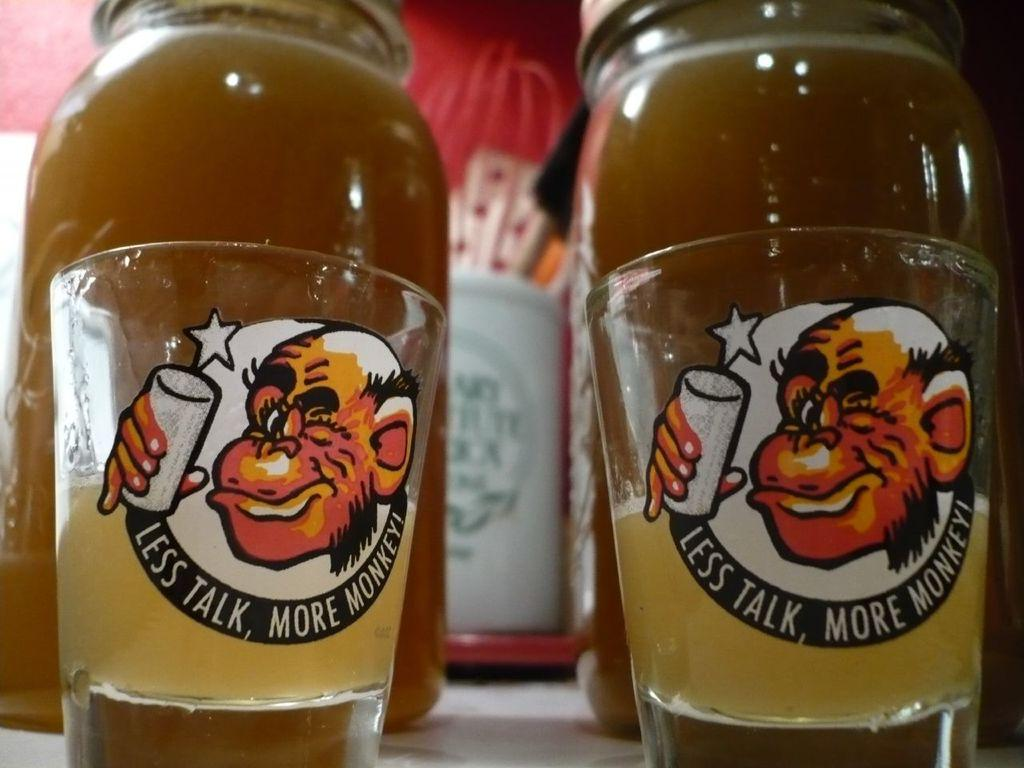What type of containers are present in the image? There are bottles with drinks in the image. What else can be seen in the image besides the bottles? There are glasses in the image. How are the glasses decorated or marked? Stickers are attached to the glasses. What type of wheel can be seen in the image? There is no wheel present in the image. What observation can be made about the glasses in the image? The question is too vague and cannot be answered definitively based on the provided facts. Please provide a more specific question. 